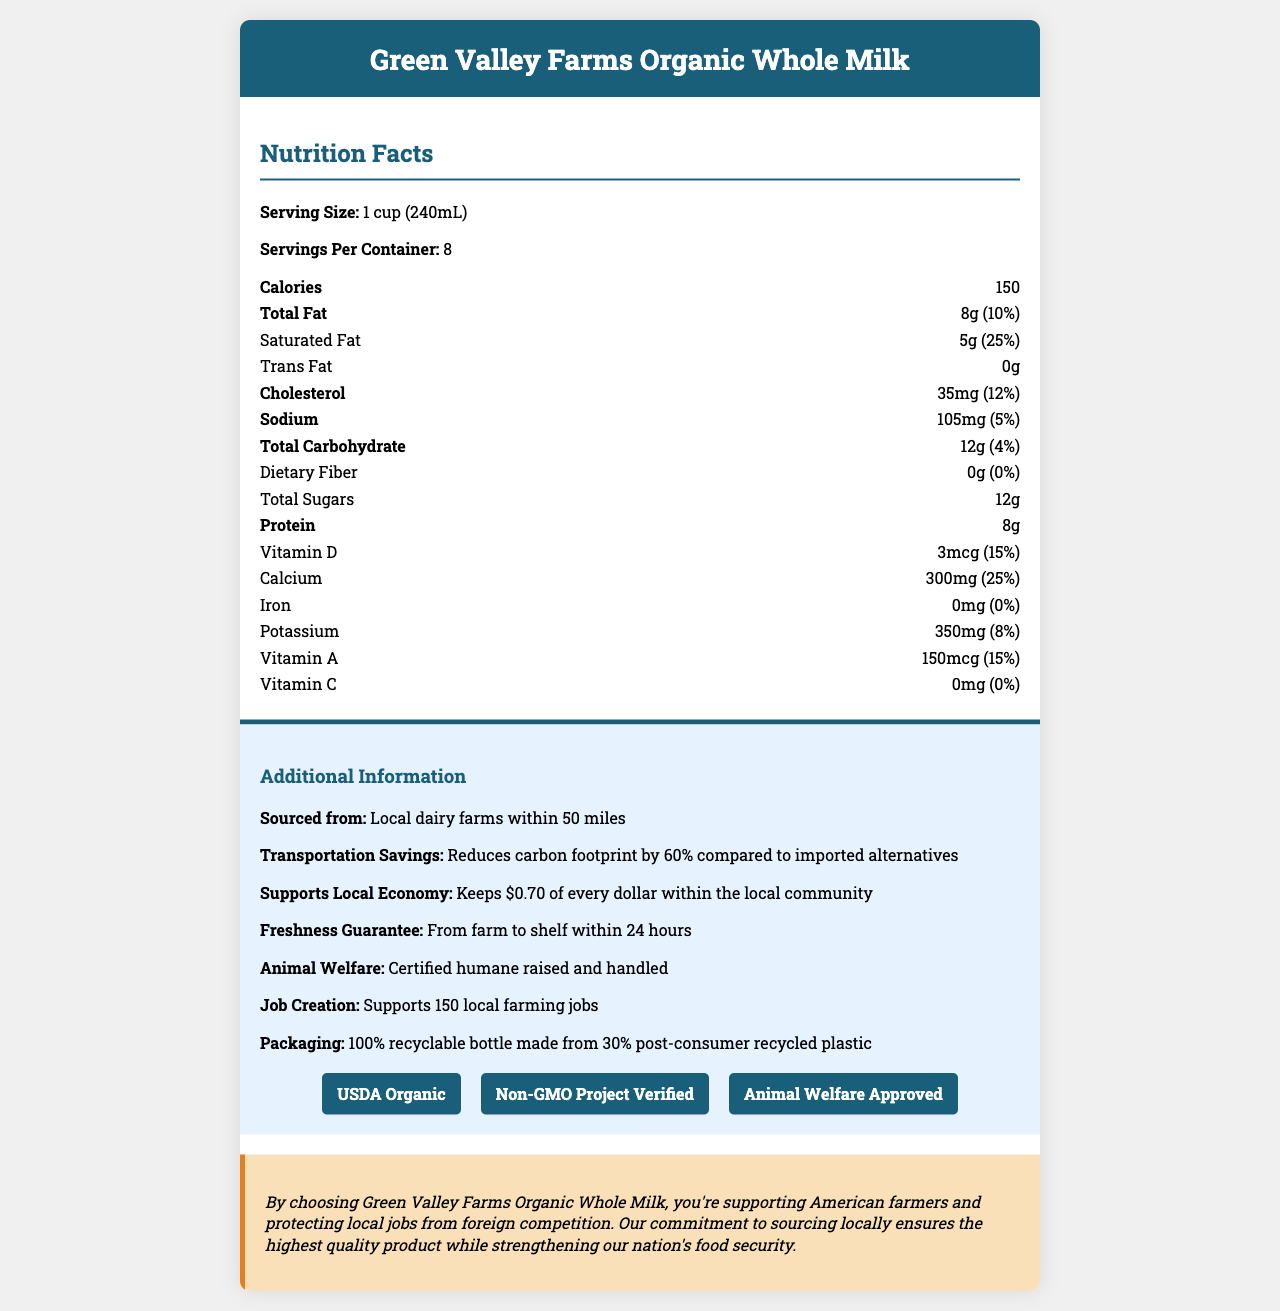What is the serving size of the Green Valley Farms Organic Whole Milk? The serving size is stated under the "Nutrition Facts" section.
Answer: 1 cup (240mL) How many calories are there per serving of the organic whole milk? The calories are listed in the "Nutrition Facts" section as 150 per serving.
Answer: 150 calories What is the daily value percentage of calcium provided per serving? The daily value percentage of calcium is listed as 25% in the "Nutrition Facts" section.
Answer: 25% How much protein is there per serving in the Green Valley Farms Organic Whole Milk? The amount of protein per serving is listed as 8g in the "Nutrition Facts" section.
Answer: 8g From where is the Green Valley Farms Organic Whole Milk sourced? This information can be found in the "Additional Information" section under "Sourced from".
Answer: Local dairy farms within 50 miles What reduction in the carbon footprint is achieved by choosing Green Valley Farms Organic Whole Milk compared to imported alternatives? This is stated in the "Additional Information" section under "Transportation Savings".
Answer: 60% Which certification does the Green Valley Farms Organic Whole Milk not have?  
A. USDA Organic  
B. Non-GMO Project Verified  
C. Fair Trade Certified  
D. Animal Welfare Approved The certifications listed in the document are USDA Organic, Non-GMO Project Verified, and Animal Welfare Approved. Fair Trade Certified is not mentioned.
Answer: C. Fair Trade Certified How much cholesterol is there in one serving of the organic whole milk? A. 10mg B. 20mg C. 35mg D. 50mg The amount of cholesterol per serving is specified as 35mg in the "Nutrition Facts" section.
Answer: C. 35mg True or False: The Green Valley Farms Organic Whole Milk supports 150 local farming jobs. This information is mentioned in the "Additional Information" section under "Job Creation".
Answer: True Summarize the main benefits of choosing Green Valley Farms Organic Whole Milk. This summary includes the main benefits outlined in the "Additional Information" and "Protectionist Statement" sections of the document.
Answer: Green Valley Farms Organic Whole Milk provides multiple benefits such as being sourced locally, which reduces transportation costs and carbon footprint by 60% compared to imported alternatives. It supports the local economy by keeping $0.70 of every dollar within the community and guarantees freshness by ensuring the product reaches the shelf within 24 hours. Additionally, it supports animal welfare, creates local jobs, and uses eco-friendly packaging. What is the exact radius within which Green Valley Farms sources its milk locally? The document only states that the milk is sourced within 50 miles, but does not specify the exact radius or coverage area.
Answer: Cannot be determined 